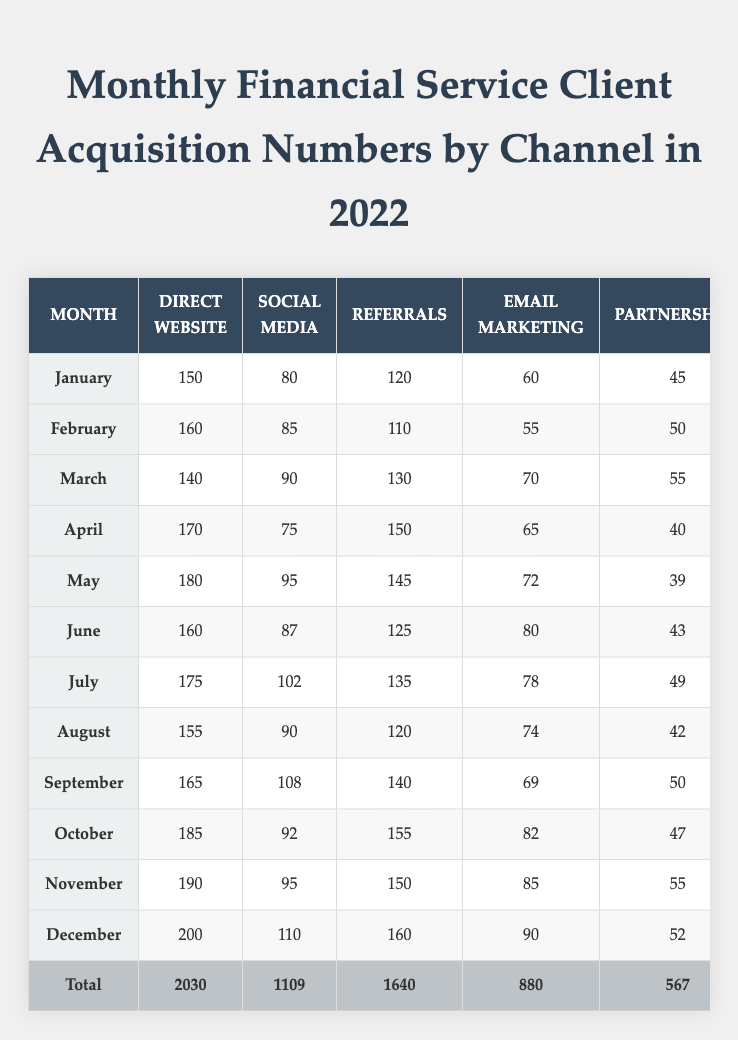What was the total client acquisition in June? By looking at the row for June in the table, we see that the total client acquisition for that month is listed as 495.
Answer: 495 Which channel had the highest number of client acquisitions in December? In the December row, we compare the numbers in each channel: Direct Website (200), Social Media (110), Referrals (160), Email Marketing (90), and Partnerships (52). The highest is Direct Website with 200.
Answer: Direct Website What is the average number of client acquisitions from Social Media across all months? To find the average, we sum the Social Media acquisitions for each month (80 + 85 + 90 + 75 + 95 + 87 + 102 + 90 + 108 + 92 + 95 + 110 = 1109), then divide by the number of months (12): 1109 / 12 = 92.42.
Answer: 92.42 Was there an increase in client acquisitions from Direct Website from November to December? The Direct Website numbers show November at 190 and December at 200, which is an increase of 10 (200 - 190 = 10).
Answer: Yes What is the total number of client acquisitions for the five channels combined in October? The total for October is specified as 561, which is the sum of all channels for that month.
Answer: 561 Which month had the highest total client acquisition? Comparing all the total numbers from each month, December has the highest total acquisition of 612.
Answer: December What was the percentage increase in Referrals from January to July? Referrals in January were 120, and in July, they were 135. Calculating the change: (135 - 120) = 15. Then, the percentage increase is (15 / 120) * 100 = 12.5%.
Answer: 12.5% In which month did Partnerships have the lowest acquisitions? Looking at the Partnerships column, the lowest value is 39, which occurs in May.
Answer: May What is the median number of client acquisitions from Email Marketing for the year? The Email Marketing numbers are: 60, 55, 70, 65, 72, 80, 78, 74, 69, 82, 85, 90. When ordered (55, 60, 65, 69, 70, 72, 74, 78, 80, 82, 85, 90) the median (average of the two middle values 72 and 74) is (72 + 74)/2 = 73.
Answer: 73 How many more clients were acquired through Referrals than Partnerships in September? In September, Referrals had 140 and Partnerships had 50. The difference is calculated as (140 - 50) = 90.
Answer: 90 